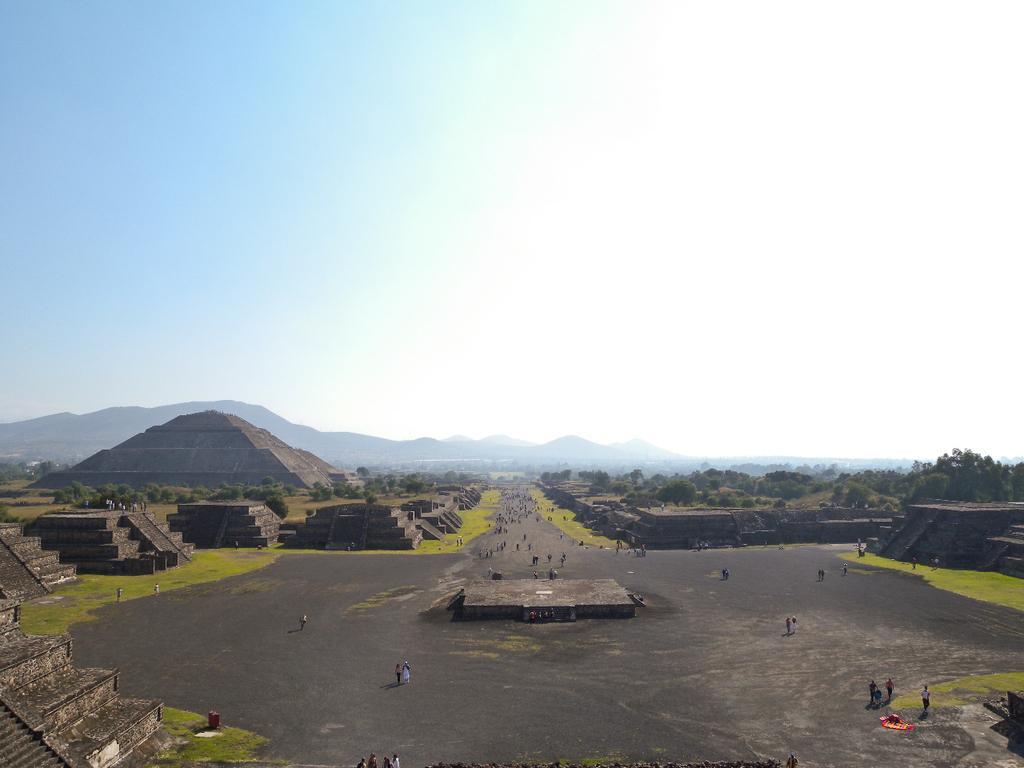Please provide a concise description of this image. In this image at the center people are walking on the road. On both right and left side of the image there are pyramids. At the background there are trees, mountains and sky. 